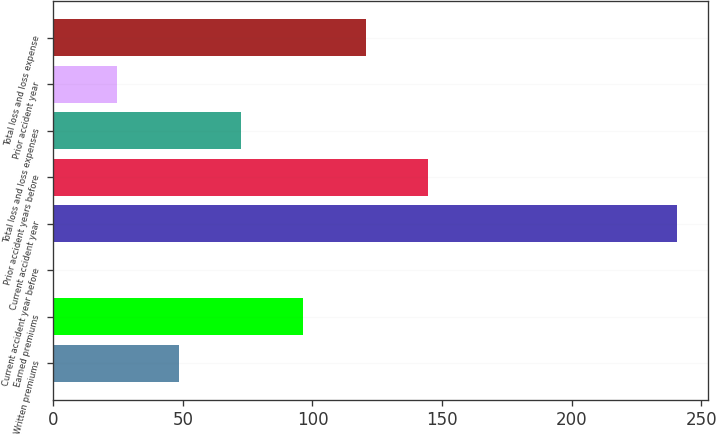<chart> <loc_0><loc_0><loc_500><loc_500><bar_chart><fcel>Written premiums<fcel>Earned premiums<fcel>Current accident year before<fcel>Current accident year<fcel>Prior accident years before<fcel>Total loss and loss expenses<fcel>Prior accident year<fcel>Total loss and loss expense<nl><fcel>48.5<fcel>96.5<fcel>0.5<fcel>240.5<fcel>144.5<fcel>72.5<fcel>24.5<fcel>120.5<nl></chart> 